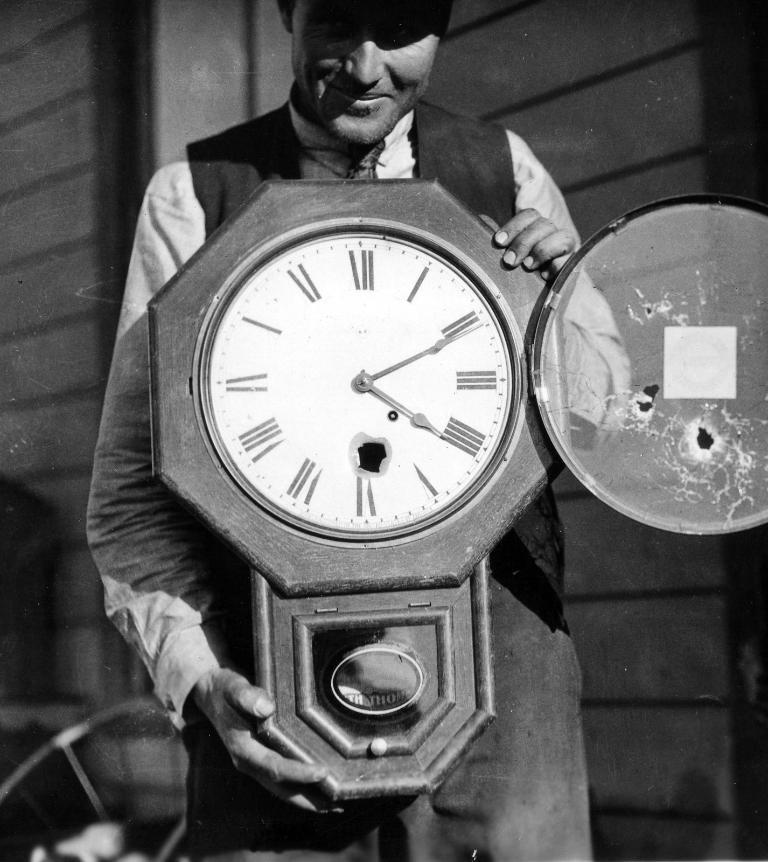Provide a one-sentence caption for the provided image. A large broken clock being held by a man is set to 4:11. 